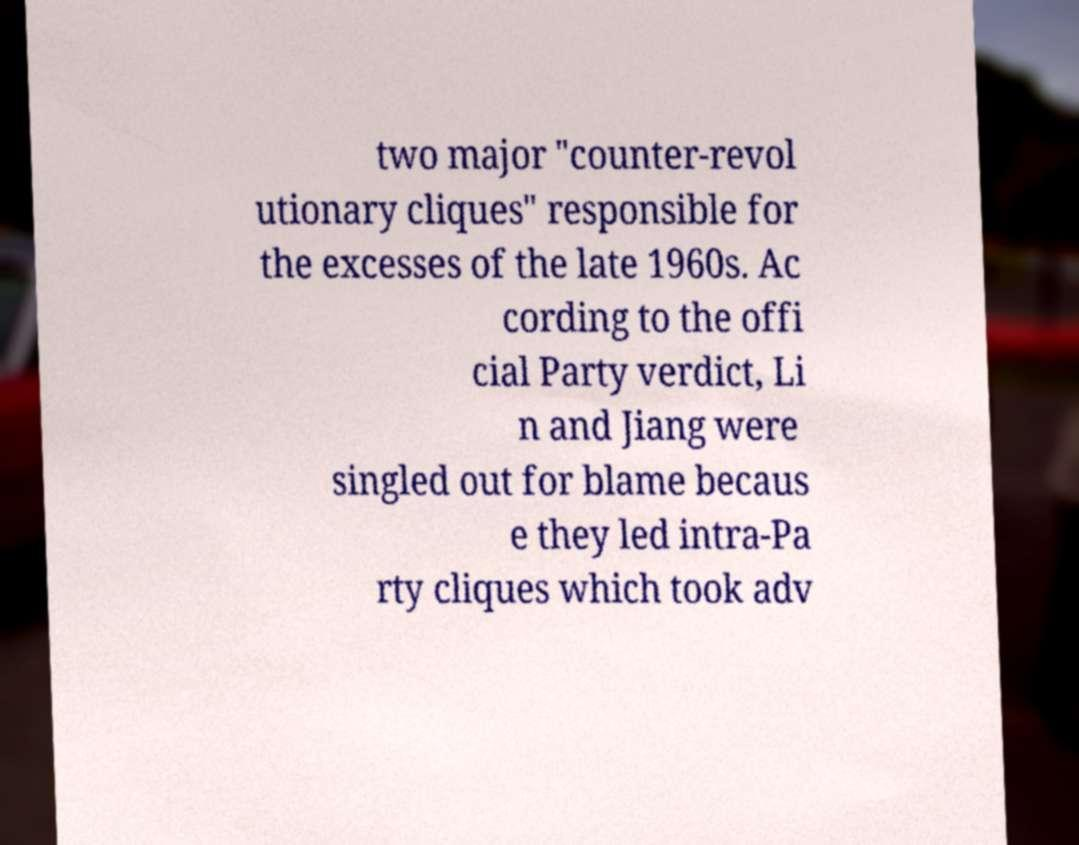What messages or text are displayed in this image? I need them in a readable, typed format. two major "counter-revol utionary cliques" responsible for the excesses of the late 1960s. Ac cording to the offi cial Party verdict, Li n and Jiang were singled out for blame becaus e they led intra-Pa rty cliques which took adv 